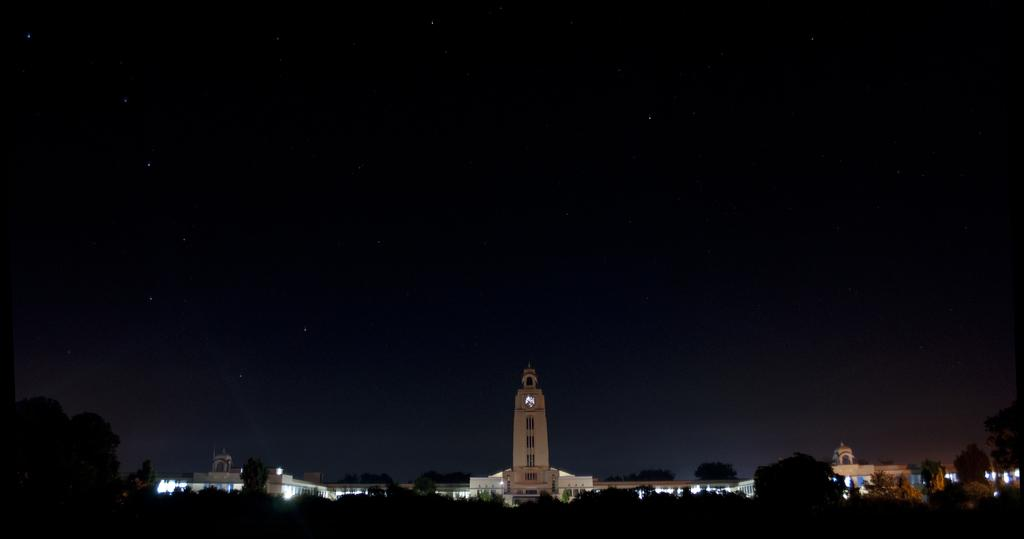What is the lighting condition in the image? The image was taken in the dark. What can be seen at the bottom of the image? There are trees and buildings at the bottom of the image. What is illuminating the bottom of the image? There are lights visible at the bottom of the image. What is visible at the top of the image? The sky is visible at the top of the image, and stars are present in the sky. What type of territory does the creature in the image inhabit? There is no creature present in the image. What kind of cracker is being used to create the lights at the bottom of the image? There are no crackers present in the image; the lights are likely from streetlights or other artificial sources. 